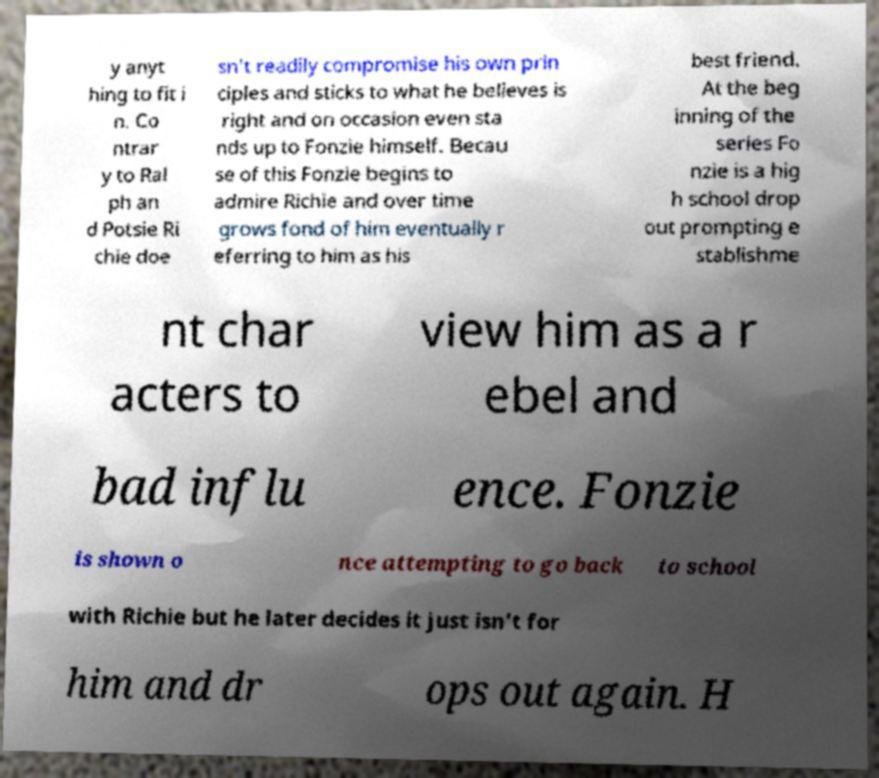Please read and relay the text visible in this image. What does it say? y anyt hing to fit i n. Co ntrar y to Ral ph an d Potsie Ri chie doe sn't readily compromise his own prin ciples and sticks to what he believes is right and on occasion even sta nds up to Fonzie himself. Becau se of this Fonzie begins to admire Richie and over time grows fond of him eventually r eferring to him as his best friend. At the beg inning of the series Fo nzie is a hig h school drop out prompting e stablishme nt char acters to view him as a r ebel and bad influ ence. Fonzie is shown o nce attempting to go back to school with Richie but he later decides it just isn't for him and dr ops out again. H 